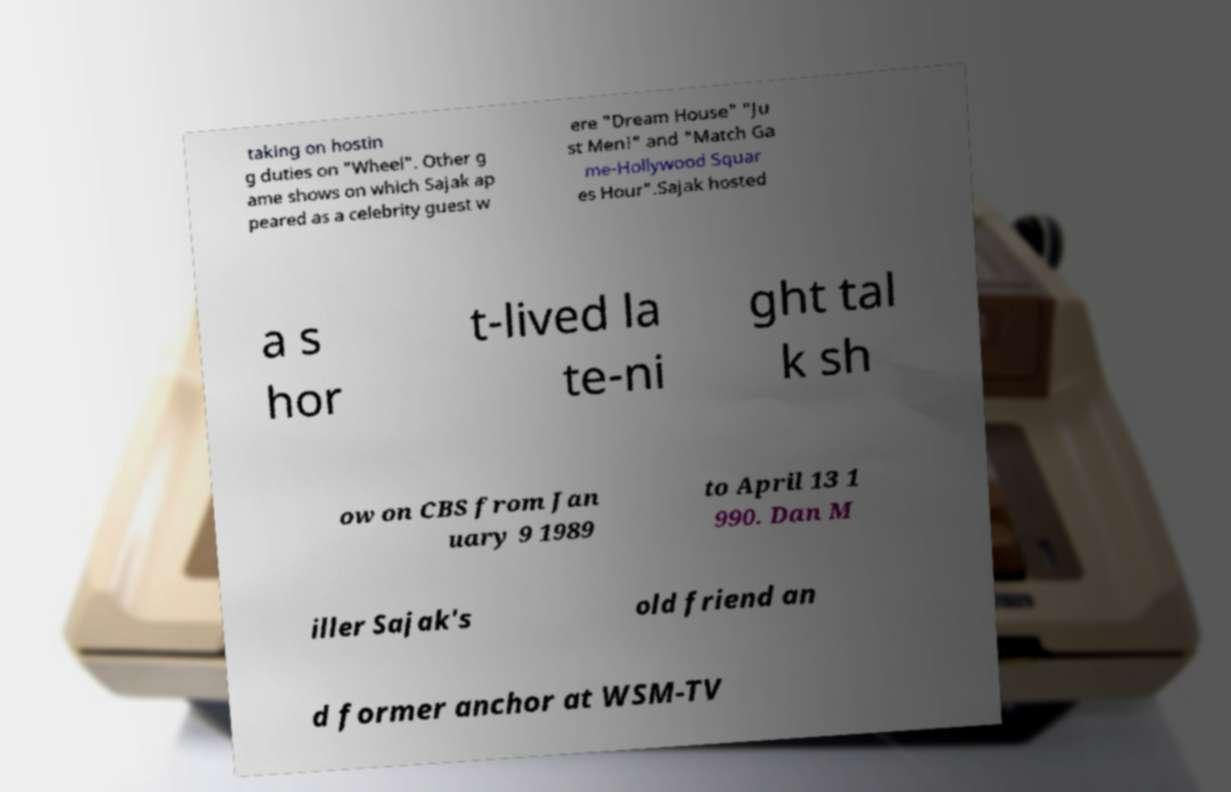Please read and relay the text visible in this image. What does it say? taking on hostin g duties on "Wheel". Other g ame shows on which Sajak ap peared as a celebrity guest w ere "Dream House" "Ju st Men!" and "Match Ga me-Hollywood Squar es Hour".Sajak hosted a s hor t-lived la te-ni ght tal k sh ow on CBS from Jan uary 9 1989 to April 13 1 990. Dan M iller Sajak's old friend an d former anchor at WSM-TV 